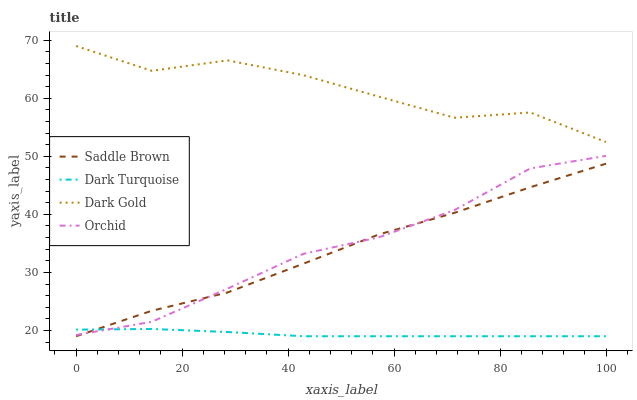Does Dark Turquoise have the minimum area under the curve?
Answer yes or no. Yes. Does Dark Gold have the maximum area under the curve?
Answer yes or no. Yes. Does Orchid have the minimum area under the curve?
Answer yes or no. No. Does Orchid have the maximum area under the curve?
Answer yes or no. No. Is Dark Turquoise the smoothest?
Answer yes or no. Yes. Is Dark Gold the roughest?
Answer yes or no. Yes. Is Orchid the smoothest?
Answer yes or no. No. Is Orchid the roughest?
Answer yes or no. No. Does Dark Turquoise have the lowest value?
Answer yes or no. Yes. Does Orchid have the lowest value?
Answer yes or no. No. Does Dark Gold have the highest value?
Answer yes or no. Yes. Does Orchid have the highest value?
Answer yes or no. No. Is Orchid less than Dark Gold?
Answer yes or no. Yes. Is Dark Gold greater than Dark Turquoise?
Answer yes or no. Yes. Does Orchid intersect Saddle Brown?
Answer yes or no. Yes. Is Orchid less than Saddle Brown?
Answer yes or no. No. Is Orchid greater than Saddle Brown?
Answer yes or no. No. Does Orchid intersect Dark Gold?
Answer yes or no. No. 